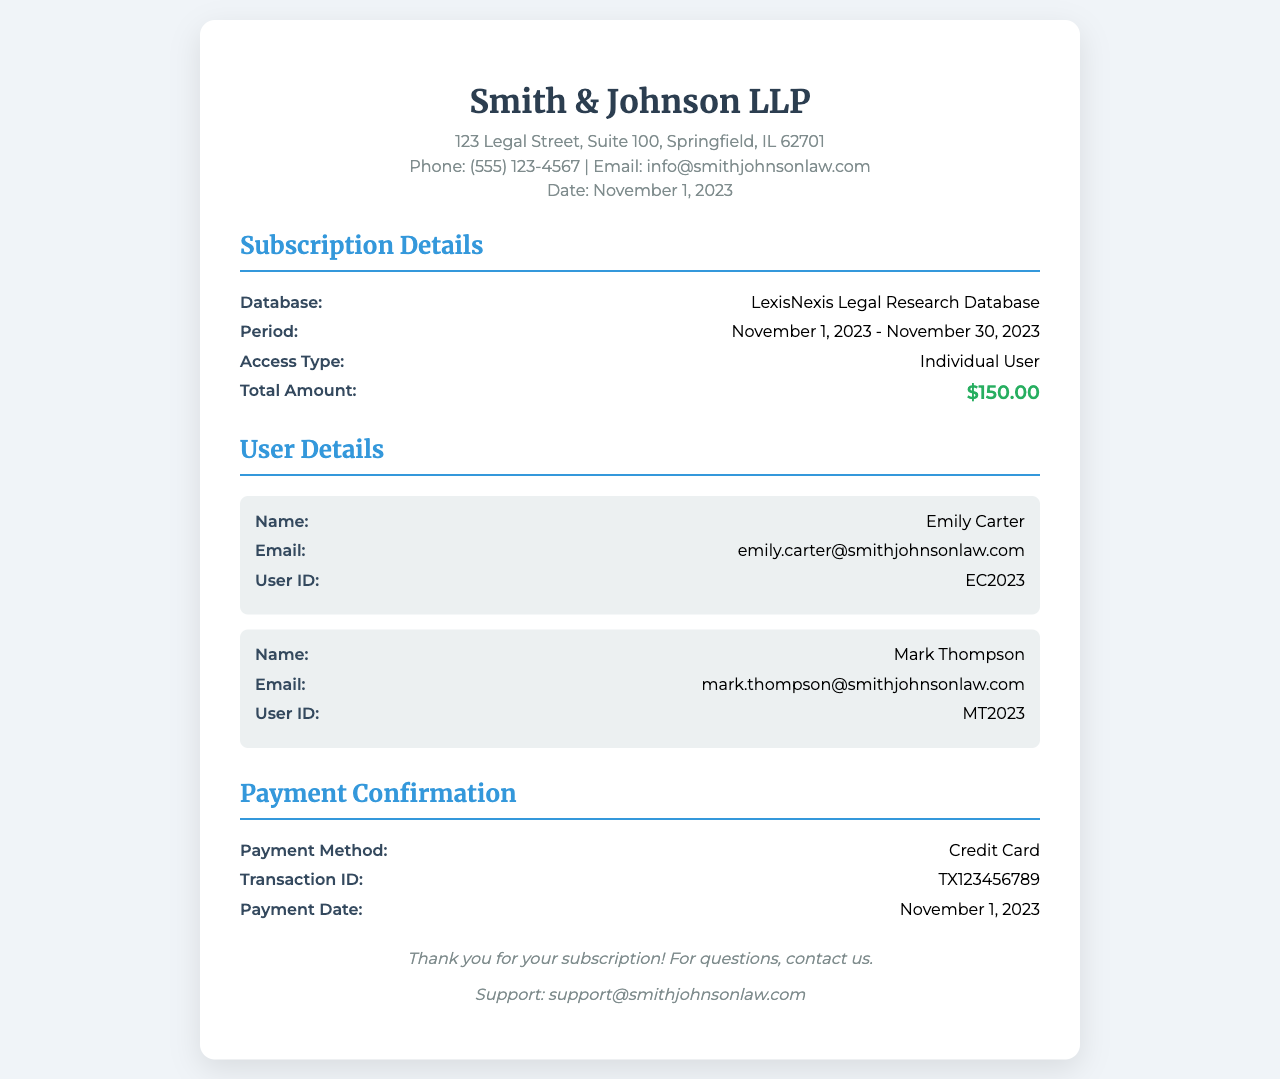What is the name of the database? The name of the database is mentioned in the subscription details section.
Answer: LexisNexis Legal Research Database What is the total amount for the subscription? The total amount is clearly stated in the subscription details section.
Answer: $150.00 Who is the first user listed on the receipt? The name of the first user is specified in the user details section.
Answer: Emily Carter What is the payment method used for this subscription? The payment method is provided in the payment confirmation section.
Answer: Credit Card What is the transaction ID for this payment? The transaction ID is indicated in the payment confirmation details.
Answer: TX123456789 What is the subscription period? The subscription period is detailed in the subscription details section.
Answer: November 1, 2023 - November 30, 2023 How many users are listed in the user details? The user details section provides a count of users listed.
Answer: Two When was the payment made? The payment date is specified in the payment confirmation section.
Answer: November 1, 2023 What is the email for support? The support email is found in the footer of the document.
Answer: support@smithjohnsonlaw.com 